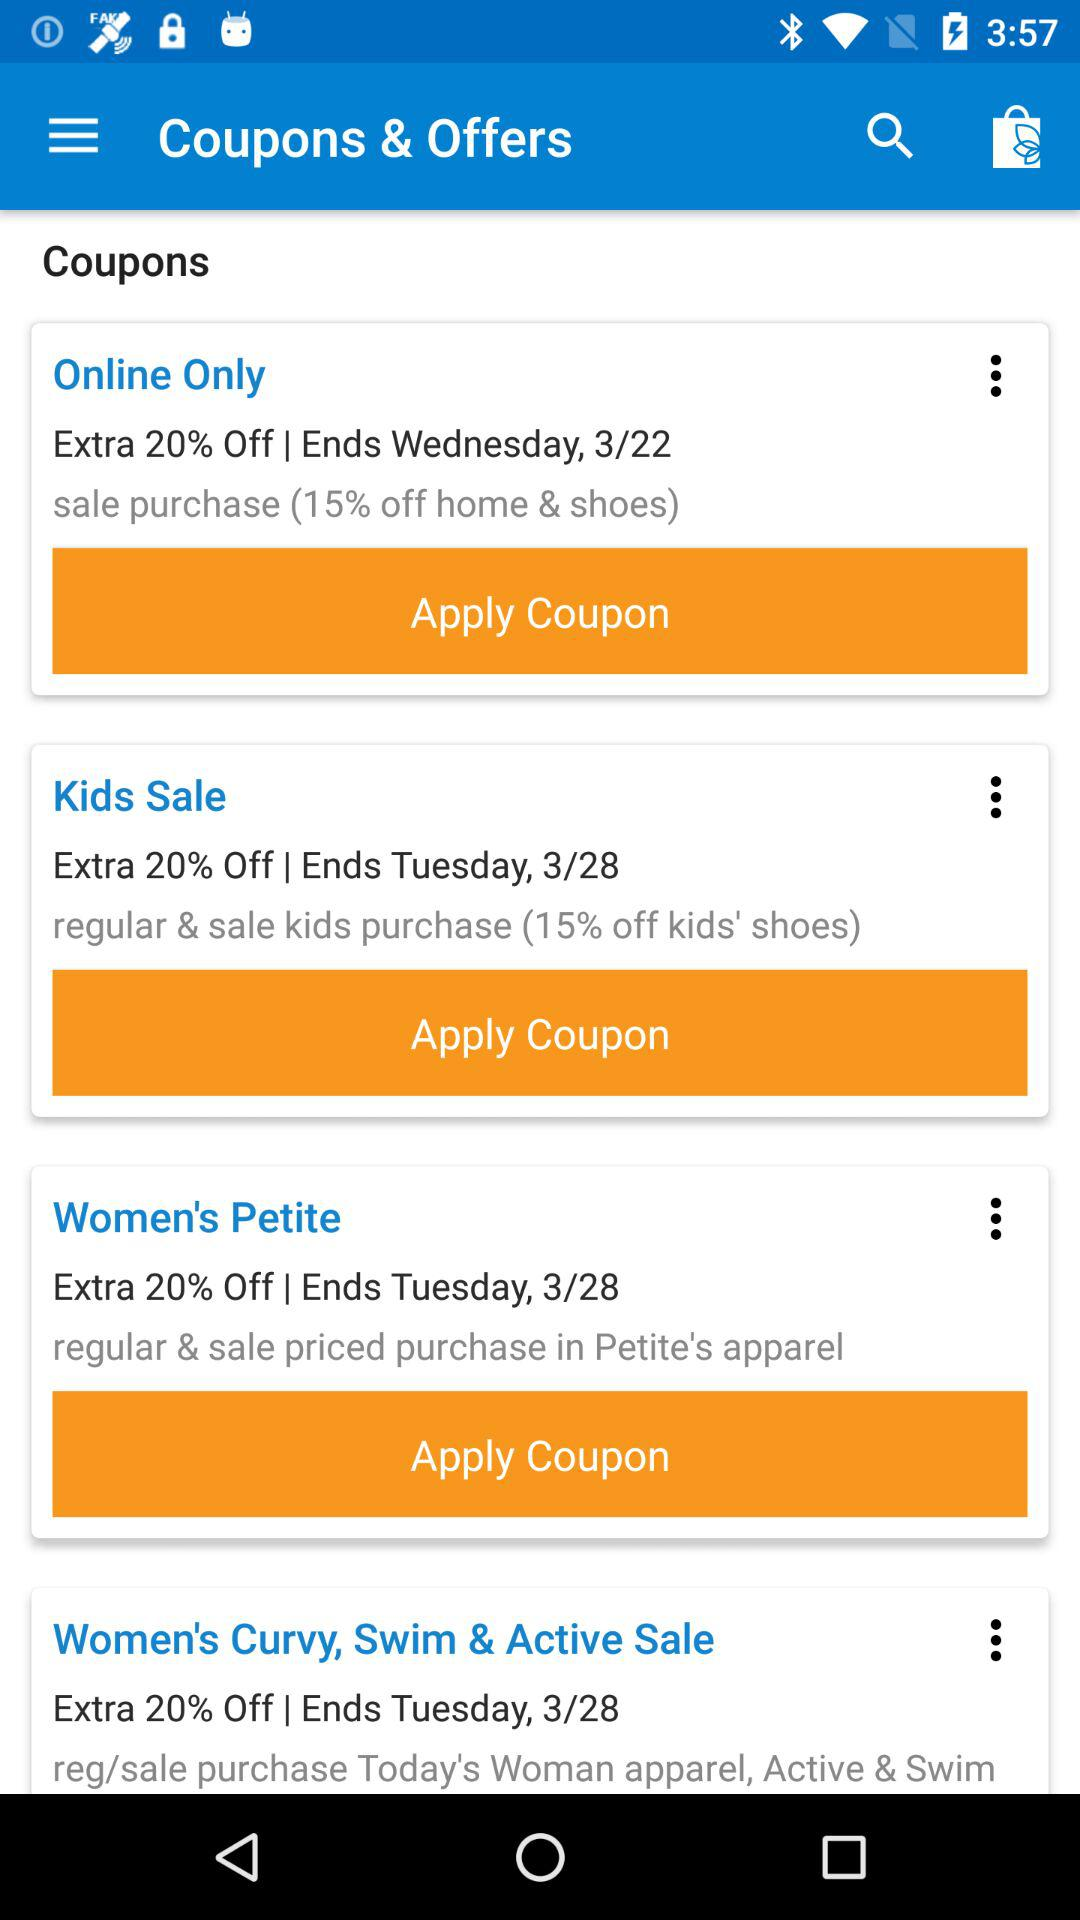How many coupons have an end date of Tuesday, 3/28?
Answer the question using a single word or phrase. 3 